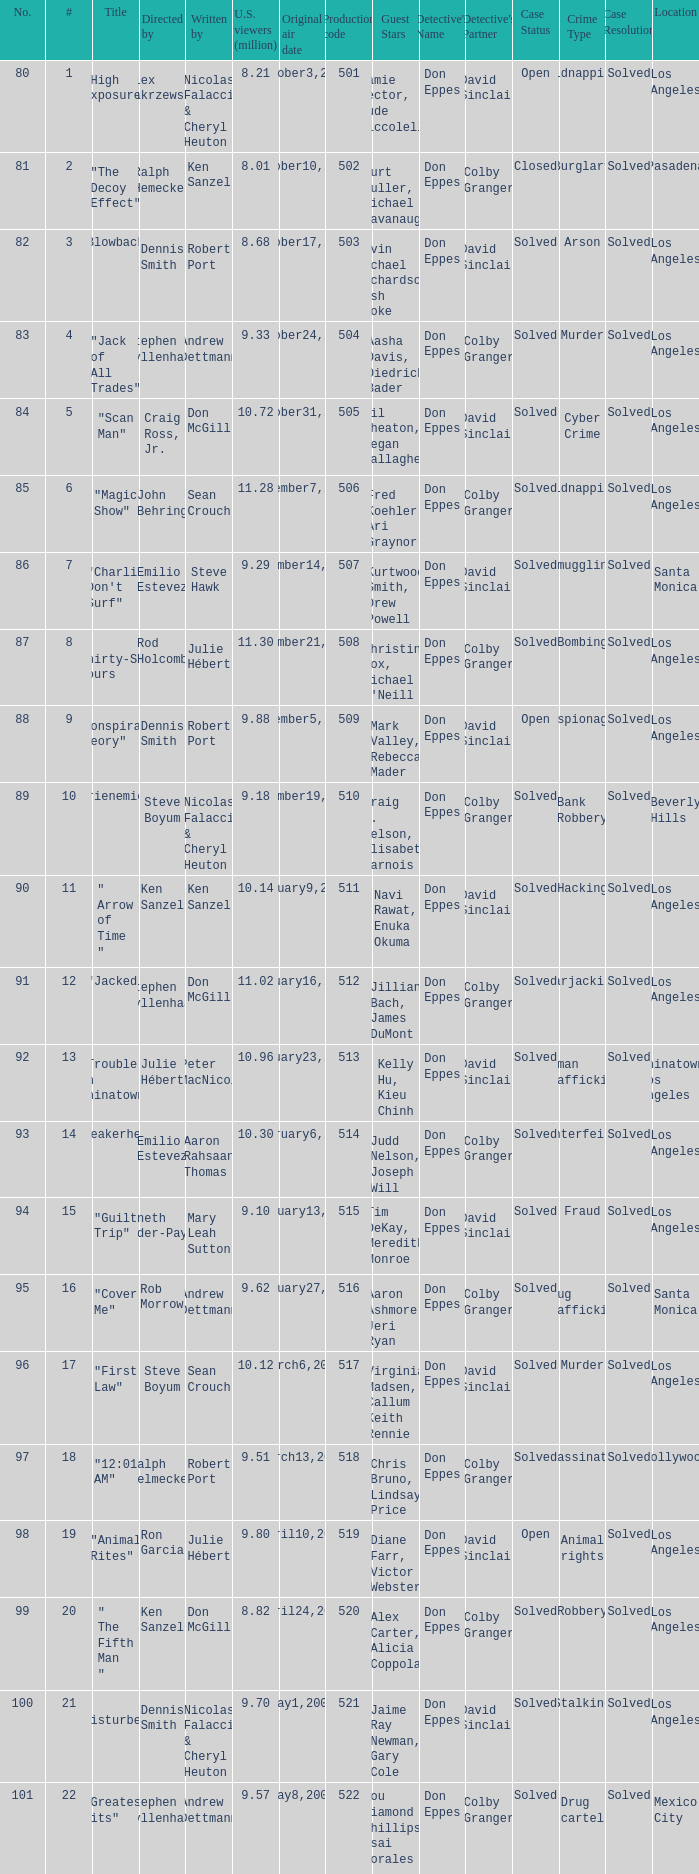Who wrote the episode with the production code 519? Julie Hébert. 